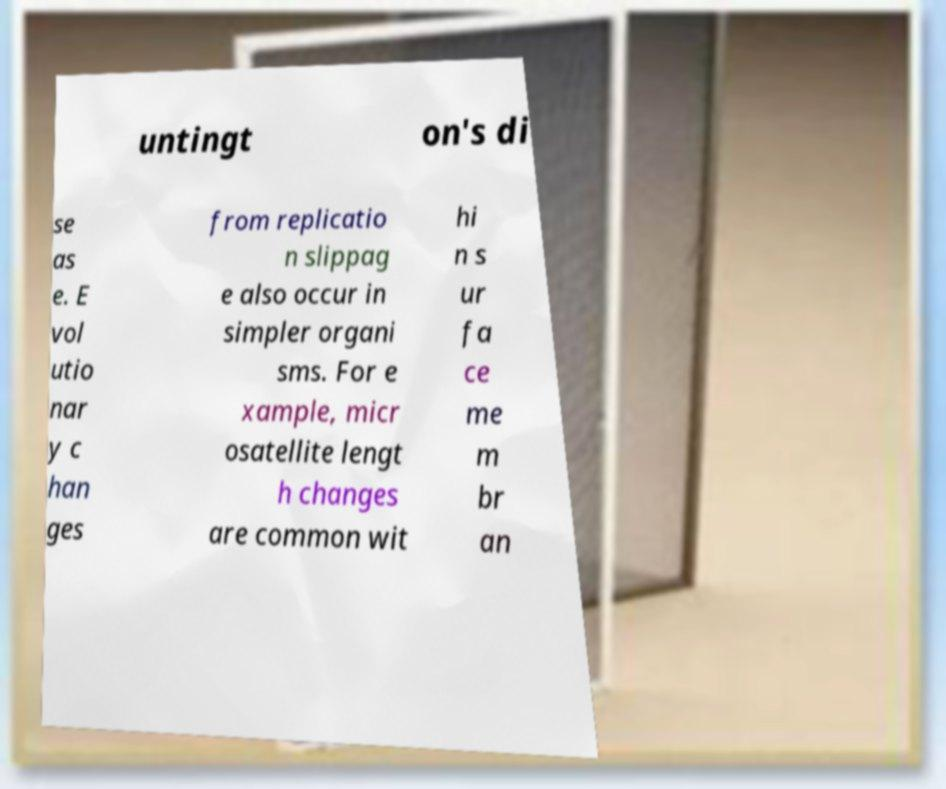There's text embedded in this image that I need extracted. Can you transcribe it verbatim? untingt on's di se as e. E vol utio nar y c han ges from replicatio n slippag e also occur in simpler organi sms. For e xample, micr osatellite lengt h changes are common wit hi n s ur fa ce me m br an 